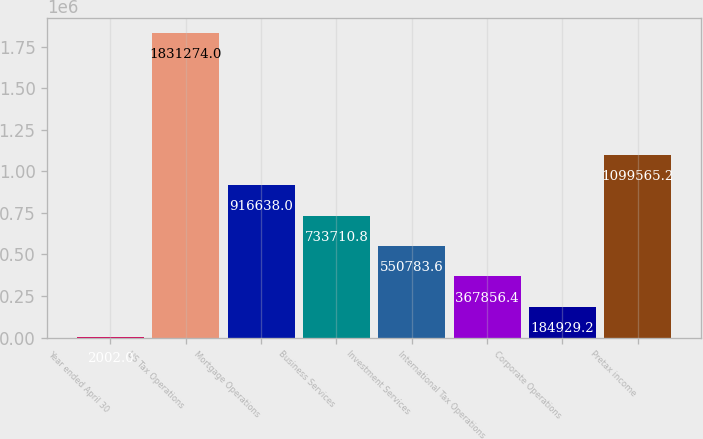Convert chart to OTSL. <chart><loc_0><loc_0><loc_500><loc_500><bar_chart><fcel>Year ended April 30<fcel>US Tax Operations<fcel>Mortgage Operations<fcel>Business Services<fcel>Investment Services<fcel>International Tax Operations<fcel>Corporate Operations<fcel>Pretax income<nl><fcel>2002<fcel>1.83127e+06<fcel>916638<fcel>733711<fcel>550784<fcel>367856<fcel>184929<fcel>1.09957e+06<nl></chart> 